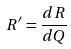<formula> <loc_0><loc_0><loc_500><loc_500>R ^ { \prime } = \frac { d R } { d Q }</formula> 